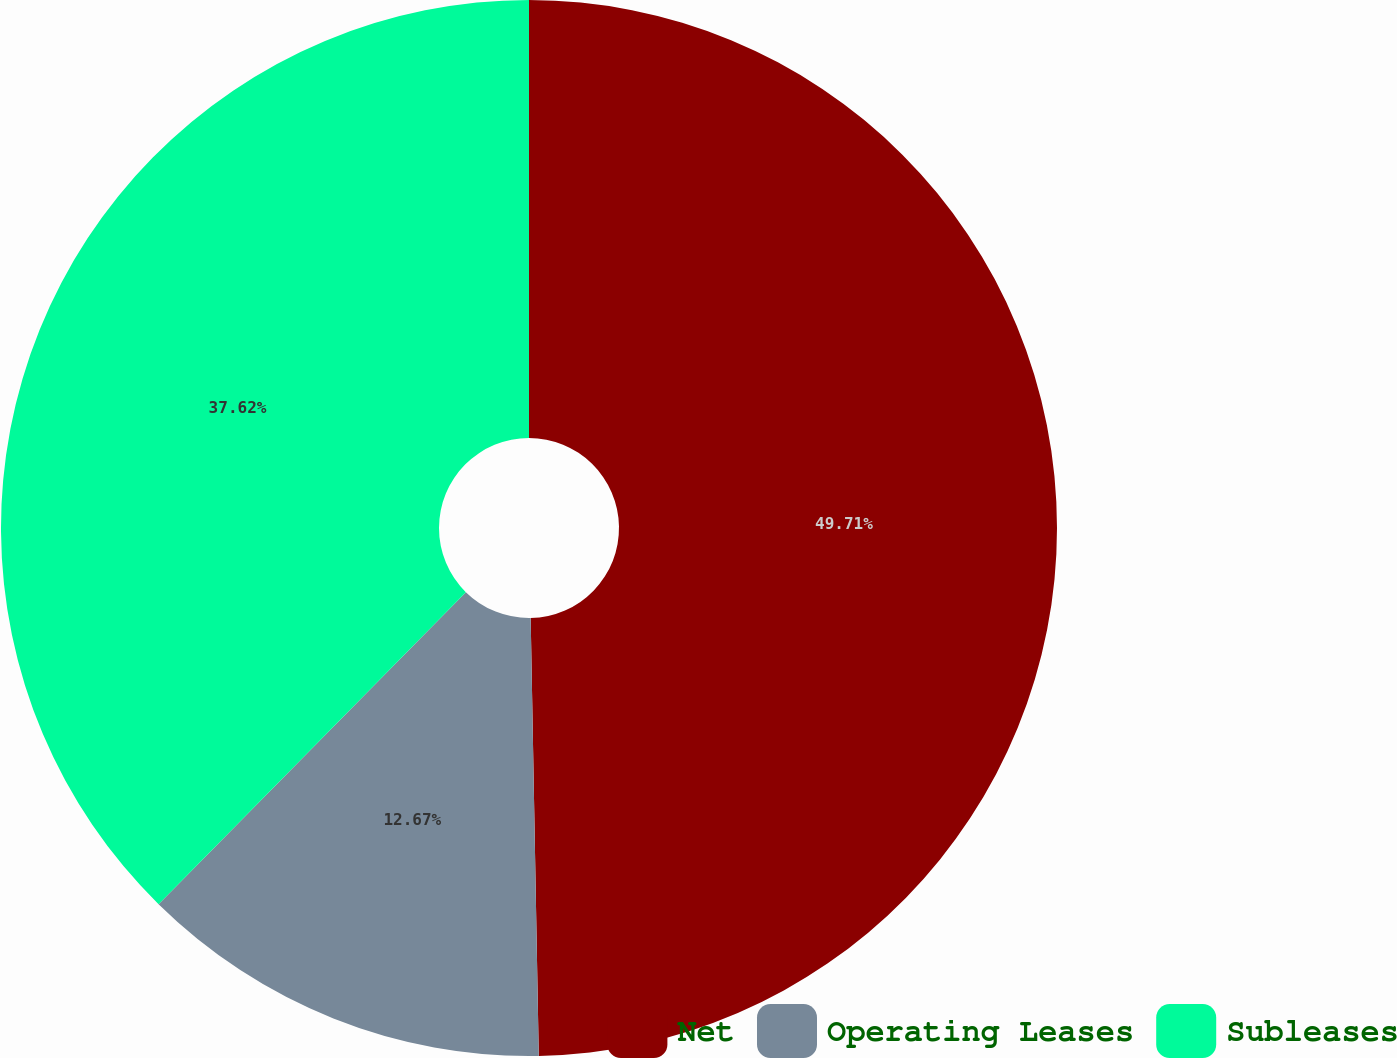Convert chart to OTSL. <chart><loc_0><loc_0><loc_500><loc_500><pie_chart><fcel>Net<fcel>Operating Leases<fcel>Subleases<nl><fcel>49.7%<fcel>12.67%<fcel>37.62%<nl></chart> 